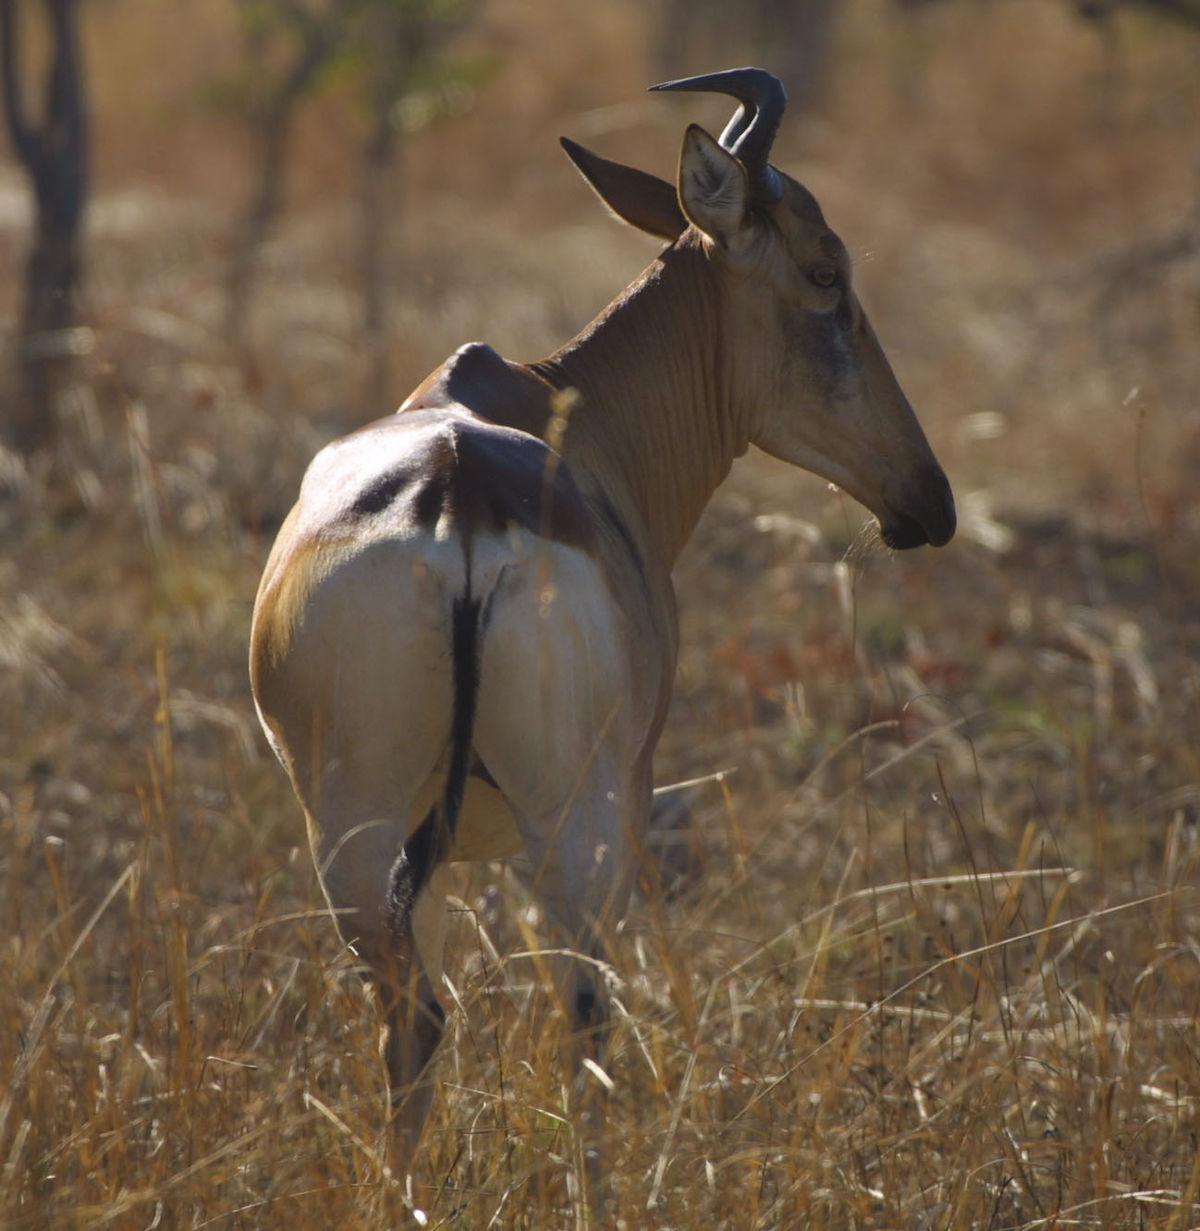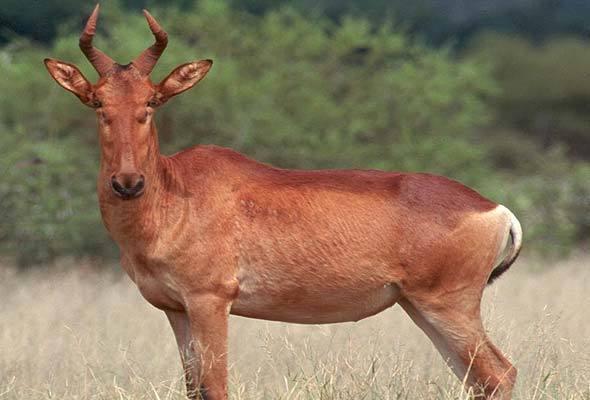The first image is the image on the left, the second image is the image on the right. For the images displayed, is the sentence "There are at most 2 animals in the image pair" factually correct? Answer yes or no. Yes. The first image is the image on the left, the second image is the image on the right. Examine the images to the left and right. Is the description "There are exactly two animals." accurate? Answer yes or no. Yes. 